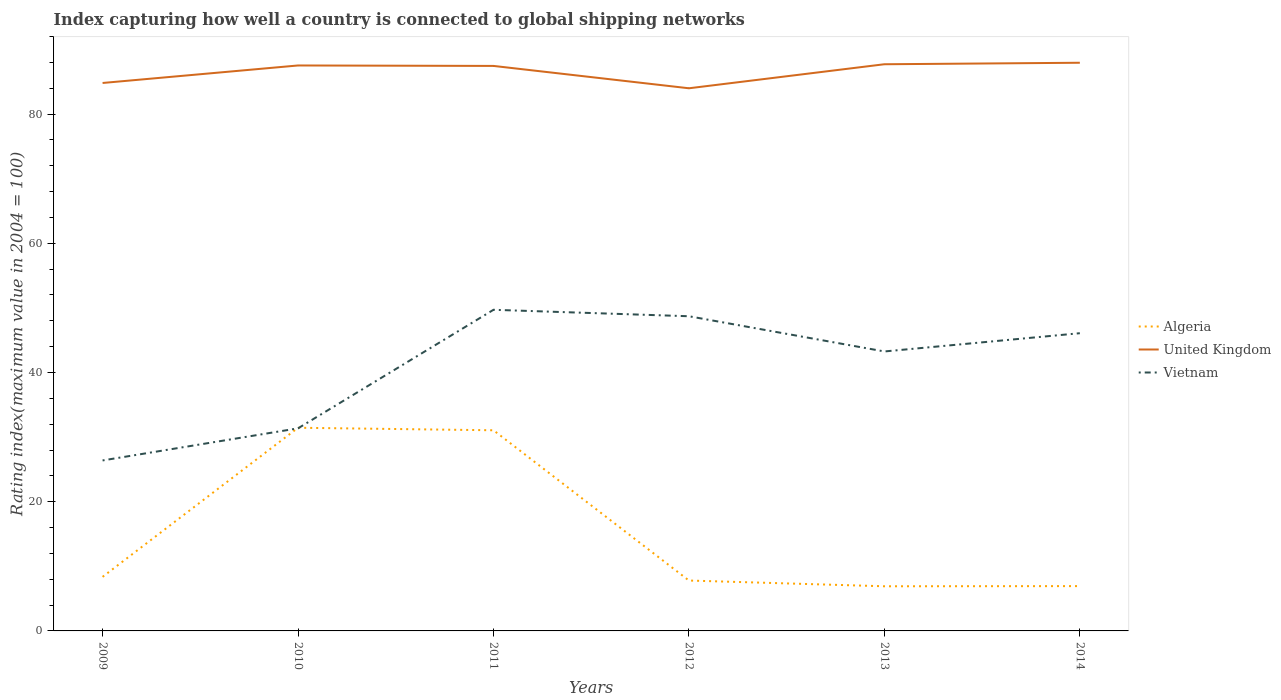How many different coloured lines are there?
Give a very brief answer. 3. Does the line corresponding to United Kingdom intersect with the line corresponding to Vietnam?
Provide a succinct answer. No. Is the number of lines equal to the number of legend labels?
Give a very brief answer. Yes. Across all years, what is the maximum rating index in Algeria?
Your answer should be very brief. 6.91. In which year was the rating index in Algeria maximum?
Ensure brevity in your answer.  2013. What is the total rating index in Algeria in the graph?
Offer a terse response. -23.08. What is the difference between the highest and the second highest rating index in Algeria?
Provide a short and direct response. 24.54. How many lines are there?
Offer a very short reply. 3. How many years are there in the graph?
Your answer should be compact. 6. What is the difference between two consecutive major ticks on the Y-axis?
Give a very brief answer. 20. Are the values on the major ticks of Y-axis written in scientific E-notation?
Give a very brief answer. No. Does the graph contain grids?
Your answer should be compact. No. How many legend labels are there?
Ensure brevity in your answer.  3. How are the legend labels stacked?
Your answer should be very brief. Vertical. What is the title of the graph?
Your answer should be very brief. Index capturing how well a country is connected to global shipping networks. Does "South Asia" appear as one of the legend labels in the graph?
Make the answer very short. No. What is the label or title of the X-axis?
Make the answer very short. Years. What is the label or title of the Y-axis?
Provide a short and direct response. Rating index(maximum value in 2004 = 100). What is the Rating index(maximum value in 2004 = 100) of Algeria in 2009?
Keep it short and to the point. 8.37. What is the Rating index(maximum value in 2004 = 100) in United Kingdom in 2009?
Your answer should be compact. 84.82. What is the Rating index(maximum value in 2004 = 100) in Vietnam in 2009?
Offer a very short reply. 26.39. What is the Rating index(maximum value in 2004 = 100) of Algeria in 2010?
Offer a very short reply. 31.45. What is the Rating index(maximum value in 2004 = 100) in United Kingdom in 2010?
Your answer should be very brief. 87.53. What is the Rating index(maximum value in 2004 = 100) of Vietnam in 2010?
Offer a terse response. 31.36. What is the Rating index(maximum value in 2004 = 100) of Algeria in 2011?
Your response must be concise. 31.06. What is the Rating index(maximum value in 2004 = 100) in United Kingdom in 2011?
Your answer should be compact. 87.46. What is the Rating index(maximum value in 2004 = 100) of Vietnam in 2011?
Provide a succinct answer. 49.71. What is the Rating index(maximum value in 2004 = 100) of United Kingdom in 2012?
Your answer should be very brief. 84. What is the Rating index(maximum value in 2004 = 100) in Vietnam in 2012?
Give a very brief answer. 48.71. What is the Rating index(maximum value in 2004 = 100) of Algeria in 2013?
Make the answer very short. 6.91. What is the Rating index(maximum value in 2004 = 100) in United Kingdom in 2013?
Give a very brief answer. 87.72. What is the Rating index(maximum value in 2004 = 100) of Vietnam in 2013?
Offer a terse response. 43.26. What is the Rating index(maximum value in 2004 = 100) in Algeria in 2014?
Provide a short and direct response. 6.94. What is the Rating index(maximum value in 2004 = 100) in United Kingdom in 2014?
Provide a succinct answer. 87.95. What is the Rating index(maximum value in 2004 = 100) of Vietnam in 2014?
Keep it short and to the point. 46.08. Across all years, what is the maximum Rating index(maximum value in 2004 = 100) in Algeria?
Keep it short and to the point. 31.45. Across all years, what is the maximum Rating index(maximum value in 2004 = 100) in United Kingdom?
Your response must be concise. 87.95. Across all years, what is the maximum Rating index(maximum value in 2004 = 100) in Vietnam?
Your answer should be very brief. 49.71. Across all years, what is the minimum Rating index(maximum value in 2004 = 100) of Algeria?
Ensure brevity in your answer.  6.91. Across all years, what is the minimum Rating index(maximum value in 2004 = 100) in Vietnam?
Provide a short and direct response. 26.39. What is the total Rating index(maximum value in 2004 = 100) of Algeria in the graph?
Make the answer very short. 92.53. What is the total Rating index(maximum value in 2004 = 100) of United Kingdom in the graph?
Keep it short and to the point. 519.48. What is the total Rating index(maximum value in 2004 = 100) in Vietnam in the graph?
Provide a succinct answer. 245.51. What is the difference between the Rating index(maximum value in 2004 = 100) of Algeria in 2009 and that in 2010?
Ensure brevity in your answer.  -23.08. What is the difference between the Rating index(maximum value in 2004 = 100) of United Kingdom in 2009 and that in 2010?
Offer a very short reply. -2.71. What is the difference between the Rating index(maximum value in 2004 = 100) of Vietnam in 2009 and that in 2010?
Your answer should be compact. -4.97. What is the difference between the Rating index(maximum value in 2004 = 100) of Algeria in 2009 and that in 2011?
Ensure brevity in your answer.  -22.69. What is the difference between the Rating index(maximum value in 2004 = 100) in United Kingdom in 2009 and that in 2011?
Ensure brevity in your answer.  -2.64. What is the difference between the Rating index(maximum value in 2004 = 100) of Vietnam in 2009 and that in 2011?
Your answer should be compact. -23.32. What is the difference between the Rating index(maximum value in 2004 = 100) of Algeria in 2009 and that in 2012?
Make the answer very short. 0.57. What is the difference between the Rating index(maximum value in 2004 = 100) in United Kingdom in 2009 and that in 2012?
Offer a terse response. 0.82. What is the difference between the Rating index(maximum value in 2004 = 100) of Vietnam in 2009 and that in 2012?
Provide a short and direct response. -22.32. What is the difference between the Rating index(maximum value in 2004 = 100) in Algeria in 2009 and that in 2013?
Provide a succinct answer. 1.46. What is the difference between the Rating index(maximum value in 2004 = 100) of United Kingdom in 2009 and that in 2013?
Offer a terse response. -2.9. What is the difference between the Rating index(maximum value in 2004 = 100) of Vietnam in 2009 and that in 2013?
Offer a terse response. -16.87. What is the difference between the Rating index(maximum value in 2004 = 100) of Algeria in 2009 and that in 2014?
Your answer should be very brief. 1.43. What is the difference between the Rating index(maximum value in 2004 = 100) in United Kingdom in 2009 and that in 2014?
Provide a succinct answer. -3.13. What is the difference between the Rating index(maximum value in 2004 = 100) in Vietnam in 2009 and that in 2014?
Offer a terse response. -19.69. What is the difference between the Rating index(maximum value in 2004 = 100) in Algeria in 2010 and that in 2011?
Provide a short and direct response. 0.39. What is the difference between the Rating index(maximum value in 2004 = 100) in United Kingdom in 2010 and that in 2011?
Provide a succinct answer. 0.07. What is the difference between the Rating index(maximum value in 2004 = 100) of Vietnam in 2010 and that in 2011?
Give a very brief answer. -18.35. What is the difference between the Rating index(maximum value in 2004 = 100) of Algeria in 2010 and that in 2012?
Make the answer very short. 23.65. What is the difference between the Rating index(maximum value in 2004 = 100) of United Kingdom in 2010 and that in 2012?
Offer a very short reply. 3.53. What is the difference between the Rating index(maximum value in 2004 = 100) of Vietnam in 2010 and that in 2012?
Your answer should be compact. -17.35. What is the difference between the Rating index(maximum value in 2004 = 100) of Algeria in 2010 and that in 2013?
Offer a very short reply. 24.54. What is the difference between the Rating index(maximum value in 2004 = 100) of United Kingdom in 2010 and that in 2013?
Make the answer very short. -0.19. What is the difference between the Rating index(maximum value in 2004 = 100) of Vietnam in 2010 and that in 2013?
Make the answer very short. -11.9. What is the difference between the Rating index(maximum value in 2004 = 100) of Algeria in 2010 and that in 2014?
Give a very brief answer. 24.51. What is the difference between the Rating index(maximum value in 2004 = 100) of United Kingdom in 2010 and that in 2014?
Provide a short and direct response. -0.42. What is the difference between the Rating index(maximum value in 2004 = 100) in Vietnam in 2010 and that in 2014?
Keep it short and to the point. -14.72. What is the difference between the Rating index(maximum value in 2004 = 100) in Algeria in 2011 and that in 2012?
Your answer should be compact. 23.26. What is the difference between the Rating index(maximum value in 2004 = 100) in United Kingdom in 2011 and that in 2012?
Keep it short and to the point. 3.46. What is the difference between the Rating index(maximum value in 2004 = 100) of Algeria in 2011 and that in 2013?
Your answer should be compact. 24.15. What is the difference between the Rating index(maximum value in 2004 = 100) in United Kingdom in 2011 and that in 2013?
Offer a terse response. -0.26. What is the difference between the Rating index(maximum value in 2004 = 100) of Vietnam in 2011 and that in 2013?
Make the answer very short. 6.45. What is the difference between the Rating index(maximum value in 2004 = 100) of Algeria in 2011 and that in 2014?
Ensure brevity in your answer.  24.12. What is the difference between the Rating index(maximum value in 2004 = 100) of United Kingdom in 2011 and that in 2014?
Your answer should be compact. -0.49. What is the difference between the Rating index(maximum value in 2004 = 100) of Vietnam in 2011 and that in 2014?
Keep it short and to the point. 3.63. What is the difference between the Rating index(maximum value in 2004 = 100) in Algeria in 2012 and that in 2013?
Provide a succinct answer. 0.89. What is the difference between the Rating index(maximum value in 2004 = 100) in United Kingdom in 2012 and that in 2013?
Keep it short and to the point. -3.72. What is the difference between the Rating index(maximum value in 2004 = 100) of Vietnam in 2012 and that in 2013?
Your response must be concise. 5.45. What is the difference between the Rating index(maximum value in 2004 = 100) in Algeria in 2012 and that in 2014?
Provide a short and direct response. 0.86. What is the difference between the Rating index(maximum value in 2004 = 100) of United Kingdom in 2012 and that in 2014?
Offer a very short reply. -3.95. What is the difference between the Rating index(maximum value in 2004 = 100) in Vietnam in 2012 and that in 2014?
Your answer should be compact. 2.63. What is the difference between the Rating index(maximum value in 2004 = 100) of Algeria in 2013 and that in 2014?
Your answer should be very brief. -0.03. What is the difference between the Rating index(maximum value in 2004 = 100) of United Kingdom in 2013 and that in 2014?
Make the answer very short. -0.23. What is the difference between the Rating index(maximum value in 2004 = 100) in Vietnam in 2013 and that in 2014?
Provide a short and direct response. -2.82. What is the difference between the Rating index(maximum value in 2004 = 100) of Algeria in 2009 and the Rating index(maximum value in 2004 = 100) of United Kingdom in 2010?
Your answer should be compact. -79.16. What is the difference between the Rating index(maximum value in 2004 = 100) in Algeria in 2009 and the Rating index(maximum value in 2004 = 100) in Vietnam in 2010?
Provide a succinct answer. -22.99. What is the difference between the Rating index(maximum value in 2004 = 100) of United Kingdom in 2009 and the Rating index(maximum value in 2004 = 100) of Vietnam in 2010?
Your response must be concise. 53.46. What is the difference between the Rating index(maximum value in 2004 = 100) of Algeria in 2009 and the Rating index(maximum value in 2004 = 100) of United Kingdom in 2011?
Your response must be concise. -79.09. What is the difference between the Rating index(maximum value in 2004 = 100) of Algeria in 2009 and the Rating index(maximum value in 2004 = 100) of Vietnam in 2011?
Your answer should be compact. -41.34. What is the difference between the Rating index(maximum value in 2004 = 100) in United Kingdom in 2009 and the Rating index(maximum value in 2004 = 100) in Vietnam in 2011?
Keep it short and to the point. 35.11. What is the difference between the Rating index(maximum value in 2004 = 100) in Algeria in 2009 and the Rating index(maximum value in 2004 = 100) in United Kingdom in 2012?
Provide a short and direct response. -75.63. What is the difference between the Rating index(maximum value in 2004 = 100) in Algeria in 2009 and the Rating index(maximum value in 2004 = 100) in Vietnam in 2012?
Offer a terse response. -40.34. What is the difference between the Rating index(maximum value in 2004 = 100) of United Kingdom in 2009 and the Rating index(maximum value in 2004 = 100) of Vietnam in 2012?
Provide a short and direct response. 36.11. What is the difference between the Rating index(maximum value in 2004 = 100) in Algeria in 2009 and the Rating index(maximum value in 2004 = 100) in United Kingdom in 2013?
Provide a short and direct response. -79.35. What is the difference between the Rating index(maximum value in 2004 = 100) of Algeria in 2009 and the Rating index(maximum value in 2004 = 100) of Vietnam in 2013?
Provide a succinct answer. -34.89. What is the difference between the Rating index(maximum value in 2004 = 100) of United Kingdom in 2009 and the Rating index(maximum value in 2004 = 100) of Vietnam in 2013?
Make the answer very short. 41.56. What is the difference between the Rating index(maximum value in 2004 = 100) in Algeria in 2009 and the Rating index(maximum value in 2004 = 100) in United Kingdom in 2014?
Provide a succinct answer. -79.58. What is the difference between the Rating index(maximum value in 2004 = 100) of Algeria in 2009 and the Rating index(maximum value in 2004 = 100) of Vietnam in 2014?
Your answer should be compact. -37.71. What is the difference between the Rating index(maximum value in 2004 = 100) in United Kingdom in 2009 and the Rating index(maximum value in 2004 = 100) in Vietnam in 2014?
Offer a very short reply. 38.74. What is the difference between the Rating index(maximum value in 2004 = 100) in Algeria in 2010 and the Rating index(maximum value in 2004 = 100) in United Kingdom in 2011?
Keep it short and to the point. -56.01. What is the difference between the Rating index(maximum value in 2004 = 100) in Algeria in 2010 and the Rating index(maximum value in 2004 = 100) in Vietnam in 2011?
Keep it short and to the point. -18.26. What is the difference between the Rating index(maximum value in 2004 = 100) in United Kingdom in 2010 and the Rating index(maximum value in 2004 = 100) in Vietnam in 2011?
Keep it short and to the point. 37.82. What is the difference between the Rating index(maximum value in 2004 = 100) of Algeria in 2010 and the Rating index(maximum value in 2004 = 100) of United Kingdom in 2012?
Provide a succinct answer. -52.55. What is the difference between the Rating index(maximum value in 2004 = 100) in Algeria in 2010 and the Rating index(maximum value in 2004 = 100) in Vietnam in 2012?
Your response must be concise. -17.26. What is the difference between the Rating index(maximum value in 2004 = 100) of United Kingdom in 2010 and the Rating index(maximum value in 2004 = 100) of Vietnam in 2012?
Your answer should be very brief. 38.82. What is the difference between the Rating index(maximum value in 2004 = 100) of Algeria in 2010 and the Rating index(maximum value in 2004 = 100) of United Kingdom in 2013?
Provide a succinct answer. -56.27. What is the difference between the Rating index(maximum value in 2004 = 100) of Algeria in 2010 and the Rating index(maximum value in 2004 = 100) of Vietnam in 2013?
Offer a terse response. -11.81. What is the difference between the Rating index(maximum value in 2004 = 100) in United Kingdom in 2010 and the Rating index(maximum value in 2004 = 100) in Vietnam in 2013?
Ensure brevity in your answer.  44.27. What is the difference between the Rating index(maximum value in 2004 = 100) in Algeria in 2010 and the Rating index(maximum value in 2004 = 100) in United Kingdom in 2014?
Keep it short and to the point. -56.5. What is the difference between the Rating index(maximum value in 2004 = 100) in Algeria in 2010 and the Rating index(maximum value in 2004 = 100) in Vietnam in 2014?
Your answer should be very brief. -14.63. What is the difference between the Rating index(maximum value in 2004 = 100) in United Kingdom in 2010 and the Rating index(maximum value in 2004 = 100) in Vietnam in 2014?
Your answer should be very brief. 41.45. What is the difference between the Rating index(maximum value in 2004 = 100) in Algeria in 2011 and the Rating index(maximum value in 2004 = 100) in United Kingdom in 2012?
Ensure brevity in your answer.  -52.94. What is the difference between the Rating index(maximum value in 2004 = 100) of Algeria in 2011 and the Rating index(maximum value in 2004 = 100) of Vietnam in 2012?
Give a very brief answer. -17.65. What is the difference between the Rating index(maximum value in 2004 = 100) in United Kingdom in 2011 and the Rating index(maximum value in 2004 = 100) in Vietnam in 2012?
Provide a succinct answer. 38.75. What is the difference between the Rating index(maximum value in 2004 = 100) of Algeria in 2011 and the Rating index(maximum value in 2004 = 100) of United Kingdom in 2013?
Provide a succinct answer. -56.66. What is the difference between the Rating index(maximum value in 2004 = 100) in United Kingdom in 2011 and the Rating index(maximum value in 2004 = 100) in Vietnam in 2013?
Give a very brief answer. 44.2. What is the difference between the Rating index(maximum value in 2004 = 100) in Algeria in 2011 and the Rating index(maximum value in 2004 = 100) in United Kingdom in 2014?
Your response must be concise. -56.89. What is the difference between the Rating index(maximum value in 2004 = 100) in Algeria in 2011 and the Rating index(maximum value in 2004 = 100) in Vietnam in 2014?
Your response must be concise. -15.02. What is the difference between the Rating index(maximum value in 2004 = 100) in United Kingdom in 2011 and the Rating index(maximum value in 2004 = 100) in Vietnam in 2014?
Offer a terse response. 41.38. What is the difference between the Rating index(maximum value in 2004 = 100) of Algeria in 2012 and the Rating index(maximum value in 2004 = 100) of United Kingdom in 2013?
Provide a succinct answer. -79.92. What is the difference between the Rating index(maximum value in 2004 = 100) in Algeria in 2012 and the Rating index(maximum value in 2004 = 100) in Vietnam in 2013?
Keep it short and to the point. -35.46. What is the difference between the Rating index(maximum value in 2004 = 100) of United Kingdom in 2012 and the Rating index(maximum value in 2004 = 100) of Vietnam in 2013?
Your answer should be compact. 40.74. What is the difference between the Rating index(maximum value in 2004 = 100) in Algeria in 2012 and the Rating index(maximum value in 2004 = 100) in United Kingdom in 2014?
Make the answer very short. -80.15. What is the difference between the Rating index(maximum value in 2004 = 100) in Algeria in 2012 and the Rating index(maximum value in 2004 = 100) in Vietnam in 2014?
Your answer should be very brief. -38.28. What is the difference between the Rating index(maximum value in 2004 = 100) of United Kingdom in 2012 and the Rating index(maximum value in 2004 = 100) of Vietnam in 2014?
Your response must be concise. 37.92. What is the difference between the Rating index(maximum value in 2004 = 100) of Algeria in 2013 and the Rating index(maximum value in 2004 = 100) of United Kingdom in 2014?
Provide a short and direct response. -81.04. What is the difference between the Rating index(maximum value in 2004 = 100) in Algeria in 2013 and the Rating index(maximum value in 2004 = 100) in Vietnam in 2014?
Offer a very short reply. -39.17. What is the difference between the Rating index(maximum value in 2004 = 100) of United Kingdom in 2013 and the Rating index(maximum value in 2004 = 100) of Vietnam in 2014?
Offer a terse response. 41.64. What is the average Rating index(maximum value in 2004 = 100) in Algeria per year?
Offer a terse response. 15.42. What is the average Rating index(maximum value in 2004 = 100) in United Kingdom per year?
Your answer should be compact. 86.58. What is the average Rating index(maximum value in 2004 = 100) in Vietnam per year?
Offer a very short reply. 40.92. In the year 2009, what is the difference between the Rating index(maximum value in 2004 = 100) of Algeria and Rating index(maximum value in 2004 = 100) of United Kingdom?
Keep it short and to the point. -76.45. In the year 2009, what is the difference between the Rating index(maximum value in 2004 = 100) in Algeria and Rating index(maximum value in 2004 = 100) in Vietnam?
Provide a short and direct response. -18.02. In the year 2009, what is the difference between the Rating index(maximum value in 2004 = 100) in United Kingdom and Rating index(maximum value in 2004 = 100) in Vietnam?
Make the answer very short. 58.43. In the year 2010, what is the difference between the Rating index(maximum value in 2004 = 100) in Algeria and Rating index(maximum value in 2004 = 100) in United Kingdom?
Offer a terse response. -56.08. In the year 2010, what is the difference between the Rating index(maximum value in 2004 = 100) of Algeria and Rating index(maximum value in 2004 = 100) of Vietnam?
Ensure brevity in your answer.  0.09. In the year 2010, what is the difference between the Rating index(maximum value in 2004 = 100) in United Kingdom and Rating index(maximum value in 2004 = 100) in Vietnam?
Give a very brief answer. 56.17. In the year 2011, what is the difference between the Rating index(maximum value in 2004 = 100) in Algeria and Rating index(maximum value in 2004 = 100) in United Kingdom?
Your answer should be very brief. -56.4. In the year 2011, what is the difference between the Rating index(maximum value in 2004 = 100) in Algeria and Rating index(maximum value in 2004 = 100) in Vietnam?
Your response must be concise. -18.65. In the year 2011, what is the difference between the Rating index(maximum value in 2004 = 100) of United Kingdom and Rating index(maximum value in 2004 = 100) of Vietnam?
Provide a succinct answer. 37.75. In the year 2012, what is the difference between the Rating index(maximum value in 2004 = 100) in Algeria and Rating index(maximum value in 2004 = 100) in United Kingdom?
Your answer should be very brief. -76.2. In the year 2012, what is the difference between the Rating index(maximum value in 2004 = 100) in Algeria and Rating index(maximum value in 2004 = 100) in Vietnam?
Your answer should be very brief. -40.91. In the year 2012, what is the difference between the Rating index(maximum value in 2004 = 100) of United Kingdom and Rating index(maximum value in 2004 = 100) of Vietnam?
Give a very brief answer. 35.29. In the year 2013, what is the difference between the Rating index(maximum value in 2004 = 100) of Algeria and Rating index(maximum value in 2004 = 100) of United Kingdom?
Offer a very short reply. -80.81. In the year 2013, what is the difference between the Rating index(maximum value in 2004 = 100) in Algeria and Rating index(maximum value in 2004 = 100) in Vietnam?
Ensure brevity in your answer.  -36.35. In the year 2013, what is the difference between the Rating index(maximum value in 2004 = 100) of United Kingdom and Rating index(maximum value in 2004 = 100) of Vietnam?
Keep it short and to the point. 44.46. In the year 2014, what is the difference between the Rating index(maximum value in 2004 = 100) of Algeria and Rating index(maximum value in 2004 = 100) of United Kingdom?
Your answer should be very brief. -81.01. In the year 2014, what is the difference between the Rating index(maximum value in 2004 = 100) in Algeria and Rating index(maximum value in 2004 = 100) in Vietnam?
Offer a terse response. -39.15. In the year 2014, what is the difference between the Rating index(maximum value in 2004 = 100) of United Kingdom and Rating index(maximum value in 2004 = 100) of Vietnam?
Provide a succinct answer. 41.87. What is the ratio of the Rating index(maximum value in 2004 = 100) in Algeria in 2009 to that in 2010?
Give a very brief answer. 0.27. What is the ratio of the Rating index(maximum value in 2004 = 100) of United Kingdom in 2009 to that in 2010?
Provide a short and direct response. 0.97. What is the ratio of the Rating index(maximum value in 2004 = 100) of Vietnam in 2009 to that in 2010?
Your answer should be very brief. 0.84. What is the ratio of the Rating index(maximum value in 2004 = 100) in Algeria in 2009 to that in 2011?
Make the answer very short. 0.27. What is the ratio of the Rating index(maximum value in 2004 = 100) of United Kingdom in 2009 to that in 2011?
Keep it short and to the point. 0.97. What is the ratio of the Rating index(maximum value in 2004 = 100) of Vietnam in 2009 to that in 2011?
Your answer should be very brief. 0.53. What is the ratio of the Rating index(maximum value in 2004 = 100) in Algeria in 2009 to that in 2012?
Your response must be concise. 1.07. What is the ratio of the Rating index(maximum value in 2004 = 100) in United Kingdom in 2009 to that in 2012?
Ensure brevity in your answer.  1.01. What is the ratio of the Rating index(maximum value in 2004 = 100) of Vietnam in 2009 to that in 2012?
Offer a terse response. 0.54. What is the ratio of the Rating index(maximum value in 2004 = 100) of Algeria in 2009 to that in 2013?
Offer a terse response. 1.21. What is the ratio of the Rating index(maximum value in 2004 = 100) in United Kingdom in 2009 to that in 2013?
Offer a terse response. 0.97. What is the ratio of the Rating index(maximum value in 2004 = 100) in Vietnam in 2009 to that in 2013?
Keep it short and to the point. 0.61. What is the ratio of the Rating index(maximum value in 2004 = 100) in Algeria in 2009 to that in 2014?
Give a very brief answer. 1.21. What is the ratio of the Rating index(maximum value in 2004 = 100) in United Kingdom in 2009 to that in 2014?
Ensure brevity in your answer.  0.96. What is the ratio of the Rating index(maximum value in 2004 = 100) of Vietnam in 2009 to that in 2014?
Provide a short and direct response. 0.57. What is the ratio of the Rating index(maximum value in 2004 = 100) in Algeria in 2010 to that in 2011?
Your response must be concise. 1.01. What is the ratio of the Rating index(maximum value in 2004 = 100) of Vietnam in 2010 to that in 2011?
Offer a terse response. 0.63. What is the ratio of the Rating index(maximum value in 2004 = 100) in Algeria in 2010 to that in 2012?
Provide a short and direct response. 4.03. What is the ratio of the Rating index(maximum value in 2004 = 100) in United Kingdom in 2010 to that in 2012?
Give a very brief answer. 1.04. What is the ratio of the Rating index(maximum value in 2004 = 100) of Vietnam in 2010 to that in 2012?
Ensure brevity in your answer.  0.64. What is the ratio of the Rating index(maximum value in 2004 = 100) of Algeria in 2010 to that in 2013?
Keep it short and to the point. 4.55. What is the ratio of the Rating index(maximum value in 2004 = 100) in Vietnam in 2010 to that in 2013?
Your answer should be very brief. 0.72. What is the ratio of the Rating index(maximum value in 2004 = 100) of Algeria in 2010 to that in 2014?
Provide a succinct answer. 4.53. What is the ratio of the Rating index(maximum value in 2004 = 100) of United Kingdom in 2010 to that in 2014?
Your answer should be compact. 1. What is the ratio of the Rating index(maximum value in 2004 = 100) in Vietnam in 2010 to that in 2014?
Your response must be concise. 0.68. What is the ratio of the Rating index(maximum value in 2004 = 100) of Algeria in 2011 to that in 2012?
Provide a succinct answer. 3.98. What is the ratio of the Rating index(maximum value in 2004 = 100) of United Kingdom in 2011 to that in 2012?
Provide a succinct answer. 1.04. What is the ratio of the Rating index(maximum value in 2004 = 100) of Vietnam in 2011 to that in 2012?
Your response must be concise. 1.02. What is the ratio of the Rating index(maximum value in 2004 = 100) of Algeria in 2011 to that in 2013?
Provide a short and direct response. 4.49. What is the ratio of the Rating index(maximum value in 2004 = 100) of United Kingdom in 2011 to that in 2013?
Offer a very short reply. 1. What is the ratio of the Rating index(maximum value in 2004 = 100) in Vietnam in 2011 to that in 2013?
Provide a succinct answer. 1.15. What is the ratio of the Rating index(maximum value in 2004 = 100) in Algeria in 2011 to that in 2014?
Your response must be concise. 4.48. What is the ratio of the Rating index(maximum value in 2004 = 100) of United Kingdom in 2011 to that in 2014?
Give a very brief answer. 0.99. What is the ratio of the Rating index(maximum value in 2004 = 100) in Vietnam in 2011 to that in 2014?
Your answer should be compact. 1.08. What is the ratio of the Rating index(maximum value in 2004 = 100) of Algeria in 2012 to that in 2013?
Offer a terse response. 1.13. What is the ratio of the Rating index(maximum value in 2004 = 100) of United Kingdom in 2012 to that in 2013?
Your answer should be very brief. 0.96. What is the ratio of the Rating index(maximum value in 2004 = 100) in Vietnam in 2012 to that in 2013?
Provide a succinct answer. 1.13. What is the ratio of the Rating index(maximum value in 2004 = 100) in Algeria in 2012 to that in 2014?
Provide a succinct answer. 1.12. What is the ratio of the Rating index(maximum value in 2004 = 100) in United Kingdom in 2012 to that in 2014?
Provide a succinct answer. 0.96. What is the ratio of the Rating index(maximum value in 2004 = 100) of Vietnam in 2012 to that in 2014?
Provide a short and direct response. 1.06. What is the ratio of the Rating index(maximum value in 2004 = 100) of Vietnam in 2013 to that in 2014?
Your response must be concise. 0.94. What is the difference between the highest and the second highest Rating index(maximum value in 2004 = 100) of Algeria?
Provide a short and direct response. 0.39. What is the difference between the highest and the second highest Rating index(maximum value in 2004 = 100) in United Kingdom?
Give a very brief answer. 0.23. What is the difference between the highest and the second highest Rating index(maximum value in 2004 = 100) of Vietnam?
Your response must be concise. 1. What is the difference between the highest and the lowest Rating index(maximum value in 2004 = 100) of Algeria?
Your answer should be very brief. 24.54. What is the difference between the highest and the lowest Rating index(maximum value in 2004 = 100) in United Kingdom?
Provide a succinct answer. 3.95. What is the difference between the highest and the lowest Rating index(maximum value in 2004 = 100) of Vietnam?
Ensure brevity in your answer.  23.32. 